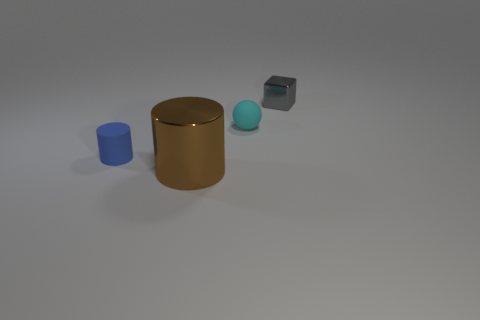Add 4 tiny red shiny objects. How many objects exist? 8 Subtract all cubes. How many objects are left? 3 Subtract 1 cyan balls. How many objects are left? 3 Subtract all brown spheres. Subtract all small cyan rubber things. How many objects are left? 3 Add 1 cylinders. How many cylinders are left? 3 Add 4 red shiny cylinders. How many red shiny cylinders exist? 4 